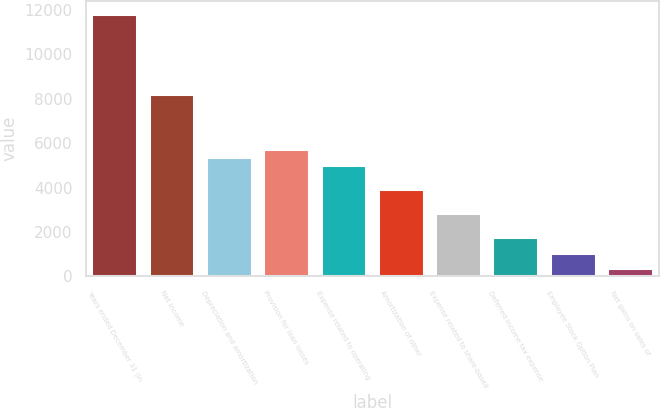Convert chart to OTSL. <chart><loc_0><loc_0><loc_500><loc_500><bar_chart><fcel>Years ended December 31 (in<fcel>Net income<fcel>Depreciation and amortization<fcel>Provision for loan losses<fcel>Expense related to operating<fcel>Amortization of other<fcel>Expense related to share-based<fcel>Deferred income tax expense<fcel>Employee Stock Option Plan<fcel>Net gains on sales of<nl><fcel>11815.6<fcel>8235.29<fcel>5371.05<fcel>5729.08<fcel>5013.02<fcel>3938.93<fcel>2864.84<fcel>1790.75<fcel>1074.69<fcel>358.63<nl></chart> 